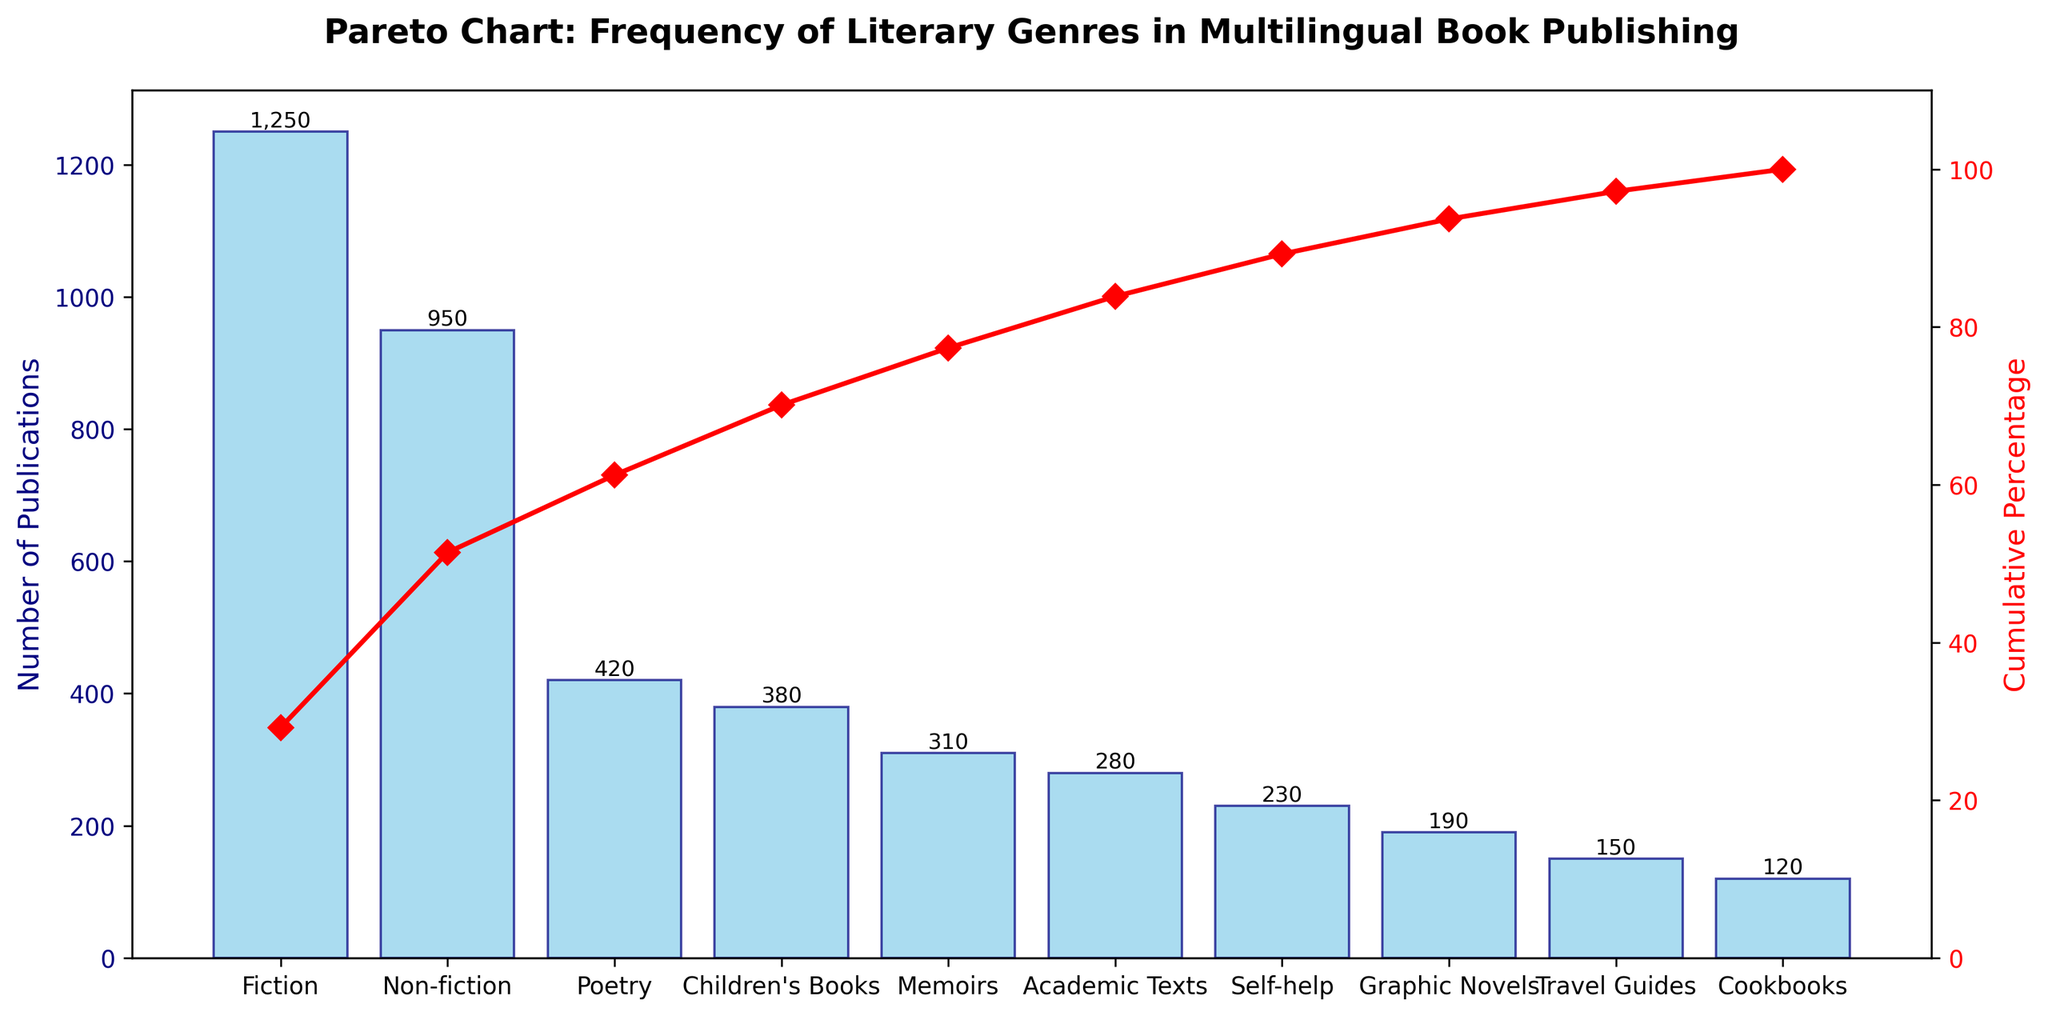what is the title of the figure? The title is displayed at the top of the figure and reads "Pareto Chart: Frequency of Literary Genres in Multilingual Book Publishing".
Answer: Pareto Chart: Frequency of Literary Genres in Multilingual Book Publishing how many literary genres are listed in the chart? There are 10 bars in the chart, each representing a different genre.
Answer: 10 which genre has the highest number of publications? Fiction has the tallest bar and the highest value label "1250" on top of it.
Answer: Fiction what is the cumulative percentage of publications covering the first three genres? Add the cumulative percentages of Fiction, Non-fiction, and Poetry. (Fiction: ~33%, Non-fiction: ~58%, Poetry: ~70%)
Answer: ~70% which genre has a lower number of publications: Memoirs or Academic Texts? The shorter bar corresponds to Academic Texts with a value of 280, lower than Memoirs with 310.
Answer: Academic Texts what percentage of the total publications do children's books contribute? The bar for Children's Books shows 380 publications, which is about 15% of the total (380 / 4280 * 100).
Answer: ~9% what is the sum of publications for the least five published genres? Add the values for Cookbooks, Travel Guides, Graphic Novels, Self-help, and Academic Texts (120 + 150 + 190 + 230 + 280 = 970).
Answer: 970 how does the number of publications for graphic novels compare to self-help books? Self-help books have 230 publications, while Graphic Novels have 190; so Graphic Novels have fewer publications.
Answer: Fewer how many genres constitute approximately 80% of the cumulative percentage of publications? This requires summing the cumulative percentages until reaching around 80%: Fiction (33%), Non-fiction (~58%), Poetry (~70%), Children's Books (~79%).
Answer: 4 what trend is depicted by the cumulative percentage line? The cumulative percentage line rises steeply at first and then levels off as more genres are added, showing a Pareto principle.
Answer: Pareto principle 